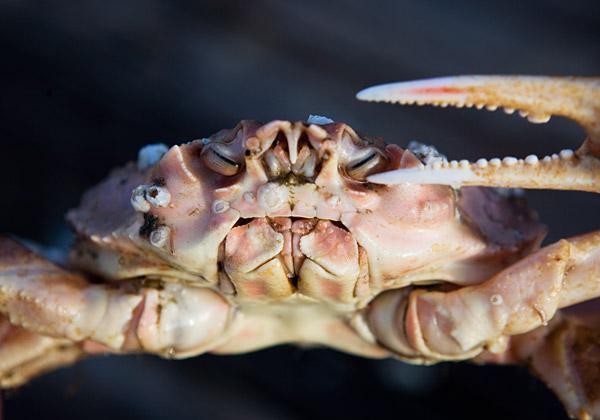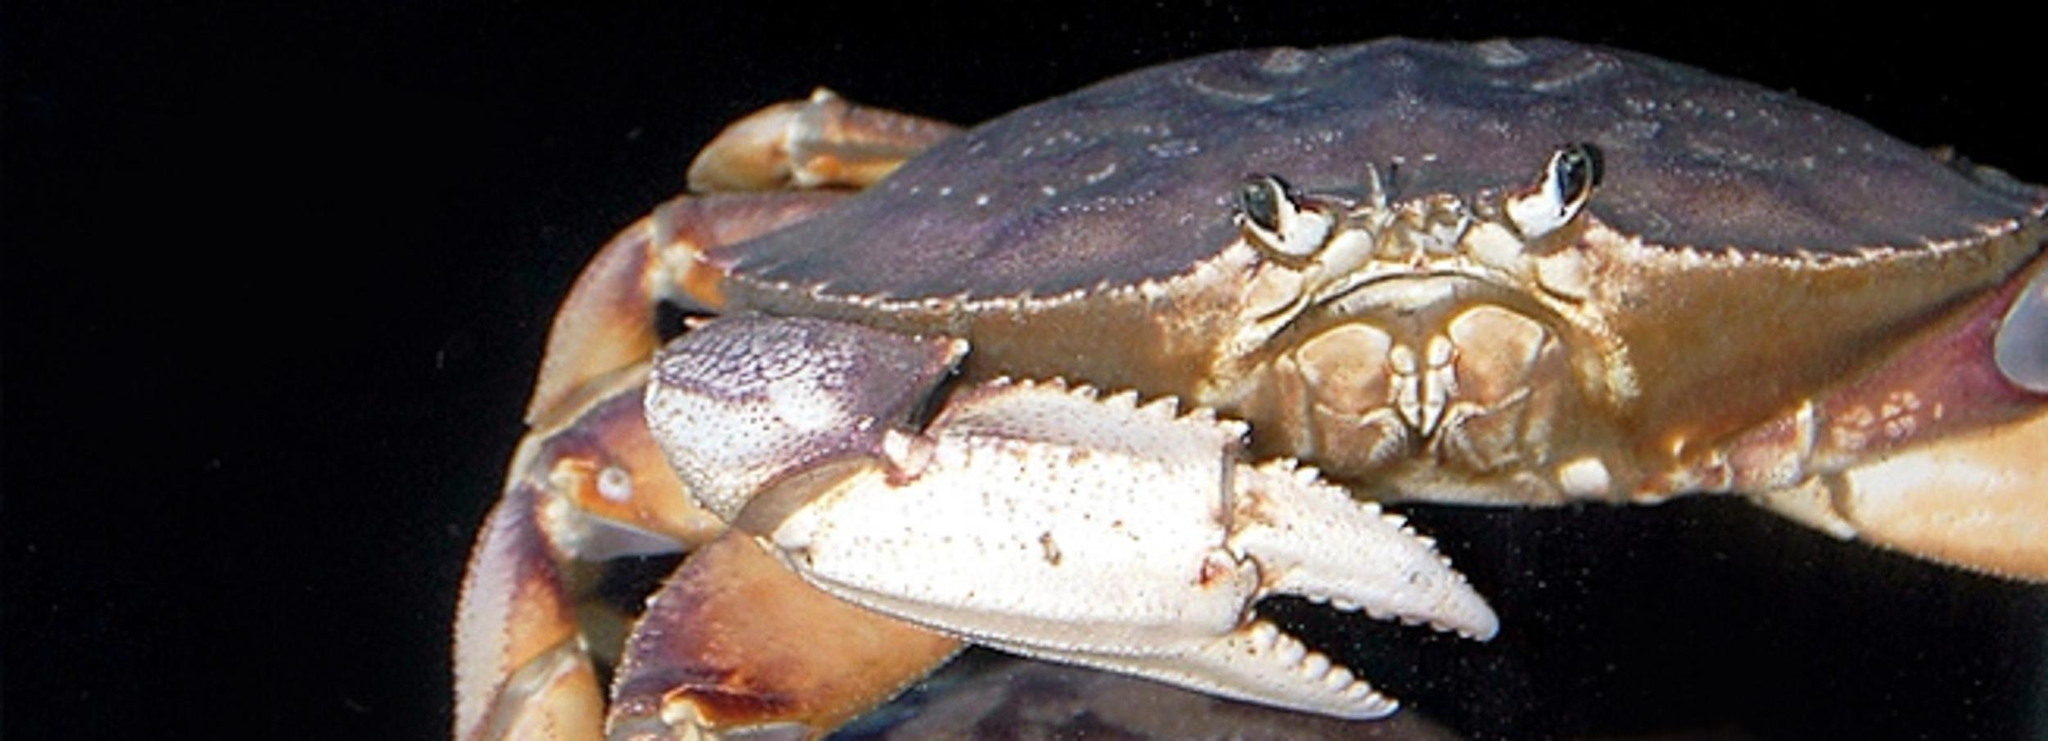The first image is the image on the left, the second image is the image on the right. For the images displayed, is the sentence "In at least one image there is a single hand holding two of the crabs legs." factually correct? Answer yes or no. No. The first image is the image on the left, the second image is the image on the right. For the images displayed, is the sentence "A bare hand is touching two of a crab's claws in one image." factually correct? Answer yes or no. No. 